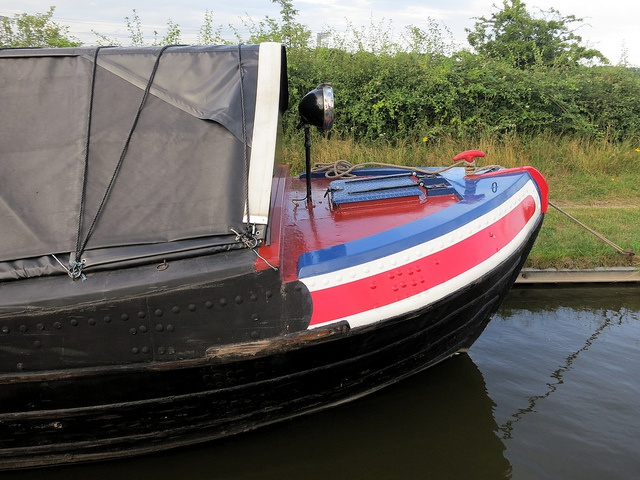Describe the objects in this image and their specific colors. I can see a boat in lightgray, black, and gray tones in this image. 